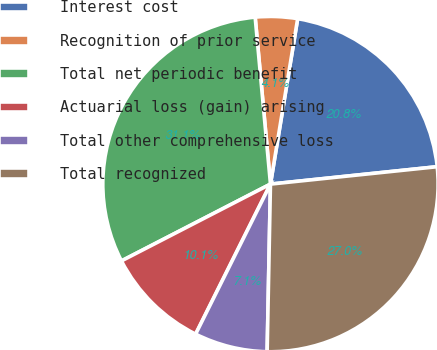Convert chart to OTSL. <chart><loc_0><loc_0><loc_500><loc_500><pie_chart><fcel>Interest cost<fcel>Recognition of prior service<fcel>Total net periodic benefit<fcel>Actuarial loss (gain) arising<fcel>Total other comprehensive loss<fcel>Total recognized<nl><fcel>20.75%<fcel>4.05%<fcel>31.12%<fcel>10.06%<fcel>7.05%<fcel>26.97%<nl></chart> 